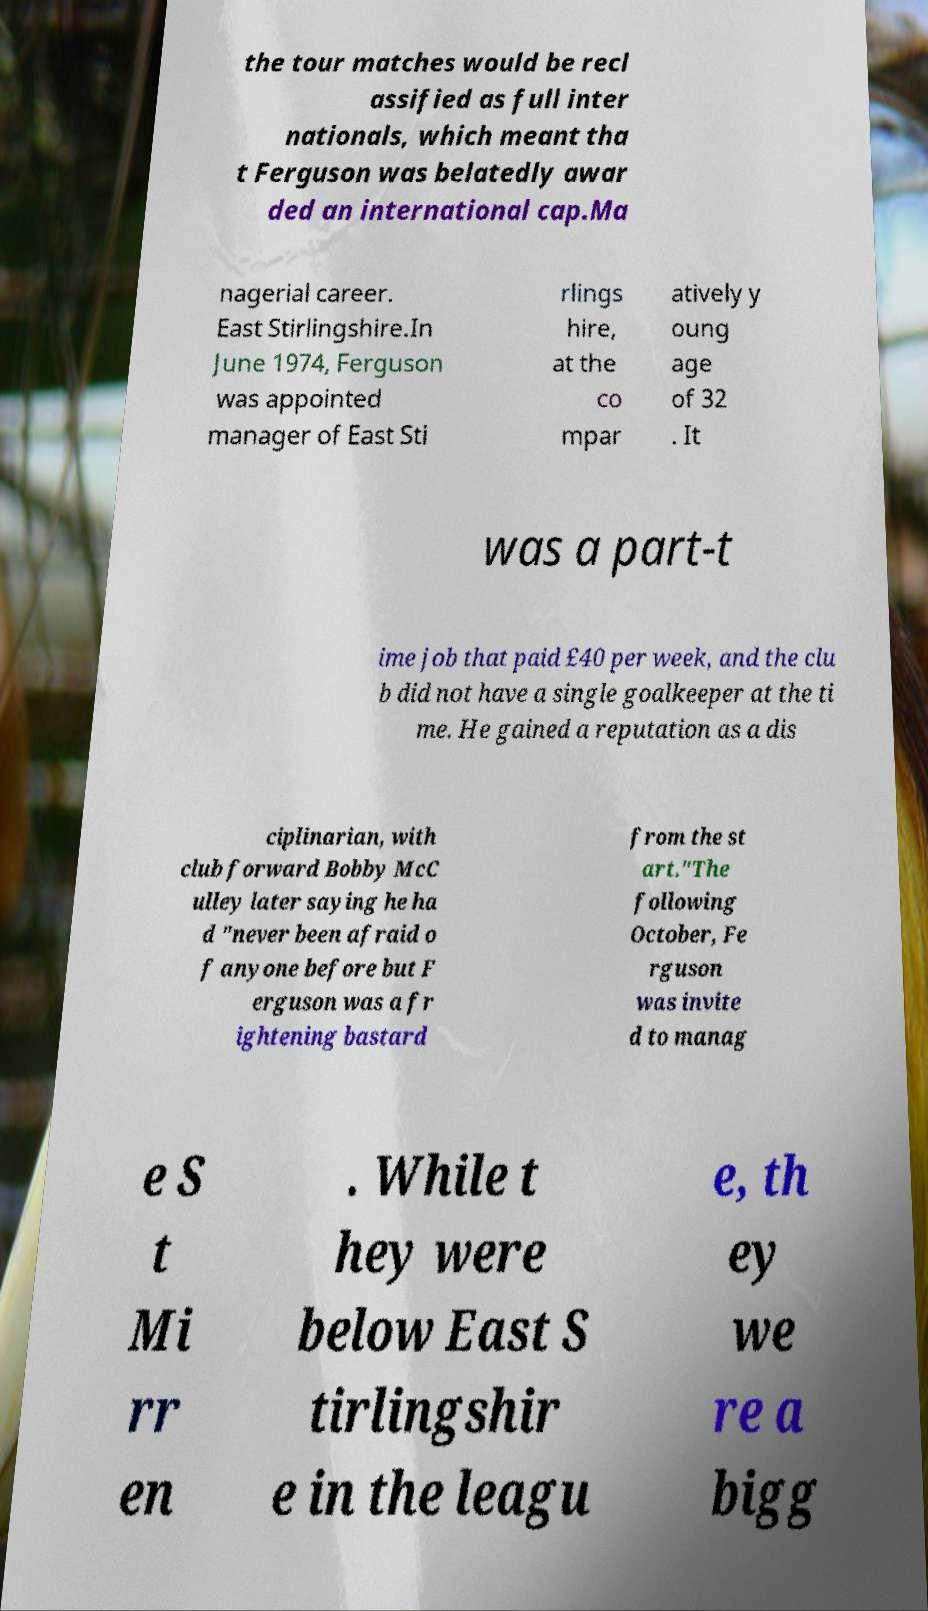For documentation purposes, I need the text within this image transcribed. Could you provide that? the tour matches would be recl assified as full inter nationals, which meant tha t Ferguson was belatedly awar ded an international cap.Ma nagerial career. East Stirlingshire.In June 1974, Ferguson was appointed manager of East Sti rlings hire, at the co mpar atively y oung age of 32 . It was a part-t ime job that paid £40 per week, and the clu b did not have a single goalkeeper at the ti me. He gained a reputation as a dis ciplinarian, with club forward Bobby McC ulley later saying he ha d "never been afraid o f anyone before but F erguson was a fr ightening bastard from the st art."The following October, Fe rguson was invite d to manag e S t Mi rr en . While t hey were below East S tirlingshir e in the leagu e, th ey we re a bigg 